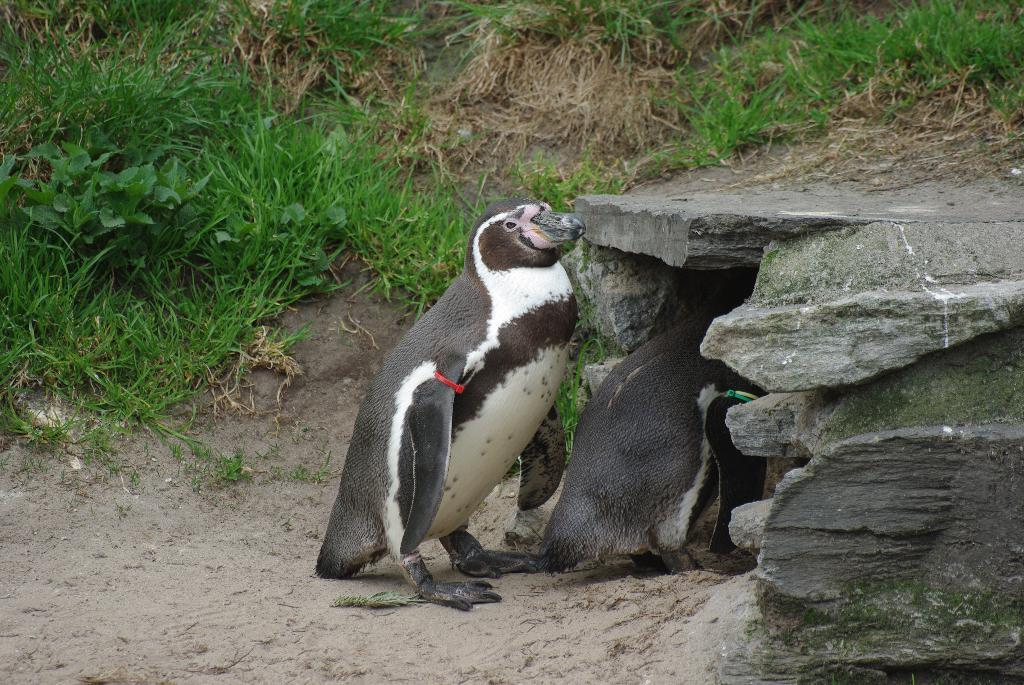What type of animals can be seen in the image? There are birds in the image. What structure is located on the right side of the image? There appears to be a den on the right side of the image. What type of vegetation is visible in the background of the image? There is grass visible in the background of the image. What type of quilt is draped over the den in the image? There is no quilt present in the image; it only features birds and a den. What is the afterthought in the image? There is no afterthought mentioned in the image; the facts provided focus on the birds, den, and grass. 